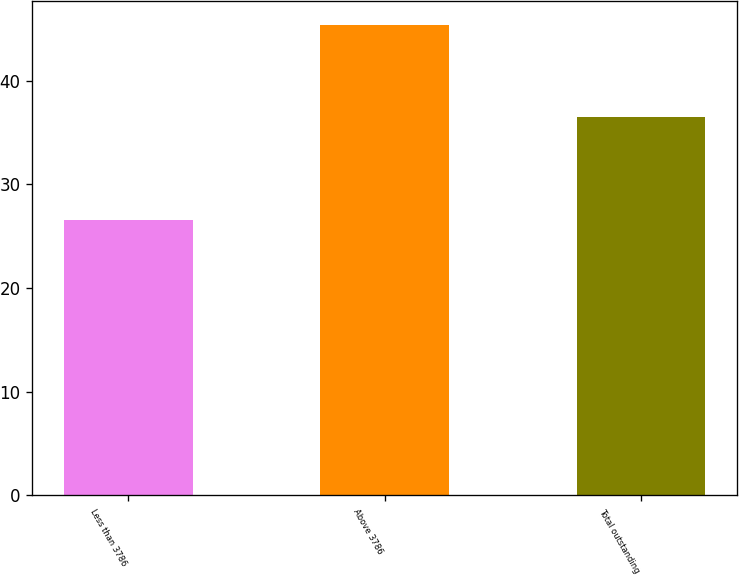Convert chart. <chart><loc_0><loc_0><loc_500><loc_500><bar_chart><fcel>Less than 3786<fcel>Above 3786<fcel>Total outstanding<nl><fcel>26.57<fcel>45.36<fcel>36.49<nl></chart> 